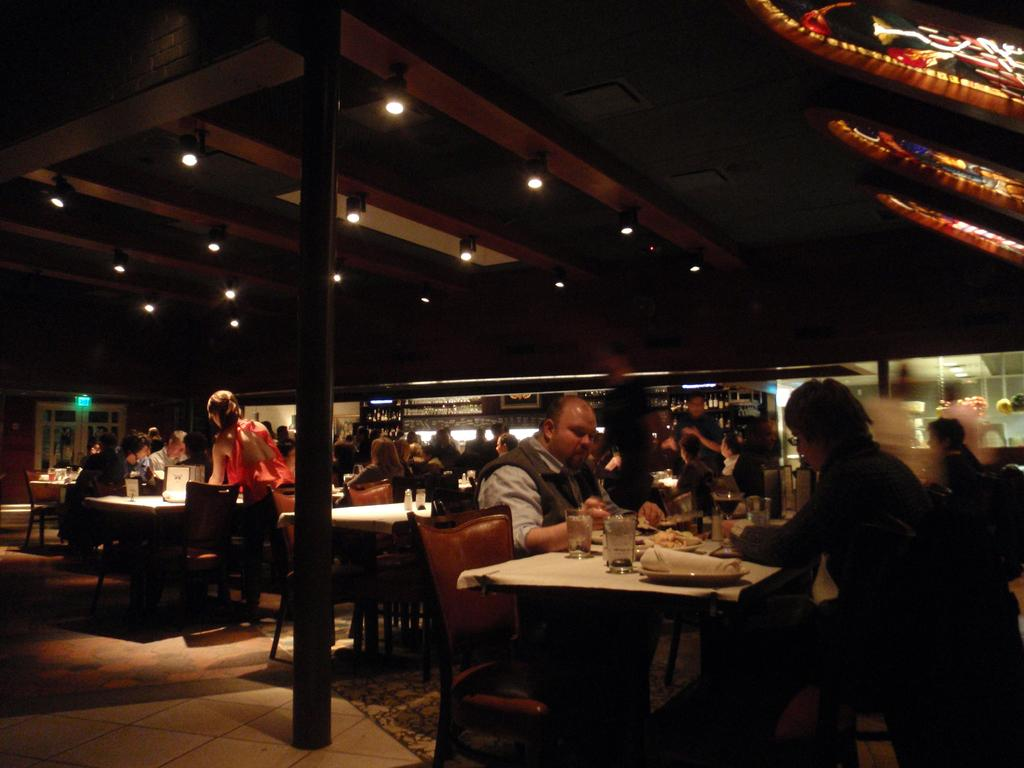What type of establishment is shown in the image? The image depicts a restaurant. What are the people in the image doing? A: The people in the image are sitting on chairs. What furniture is present in the image? Tables are present in the image. What type of table setting is visible? There is a cloth on at least one table, glasses are visible on a table, and plates are present on a table. What can be seen in the image that provides illumination? There are lights in the image. What architectural feature is present in the image? There is a pole in the image. What type of joke is being told at the table with the ornament? There is no joke or ornament present in the image. 